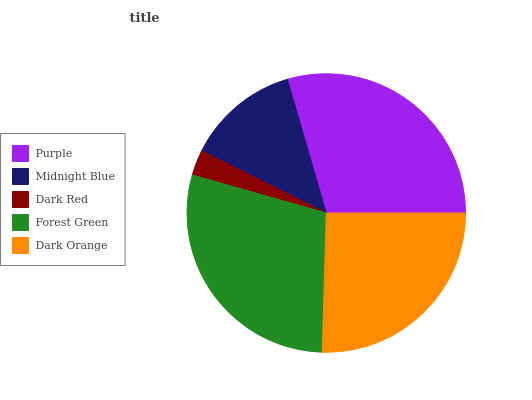Is Dark Red the minimum?
Answer yes or no. Yes. Is Purple the maximum?
Answer yes or no. Yes. Is Midnight Blue the minimum?
Answer yes or no. No. Is Midnight Blue the maximum?
Answer yes or no. No. Is Purple greater than Midnight Blue?
Answer yes or no. Yes. Is Midnight Blue less than Purple?
Answer yes or no. Yes. Is Midnight Blue greater than Purple?
Answer yes or no. No. Is Purple less than Midnight Blue?
Answer yes or no. No. Is Dark Orange the high median?
Answer yes or no. Yes. Is Dark Orange the low median?
Answer yes or no. Yes. Is Purple the high median?
Answer yes or no. No. Is Midnight Blue the low median?
Answer yes or no. No. 